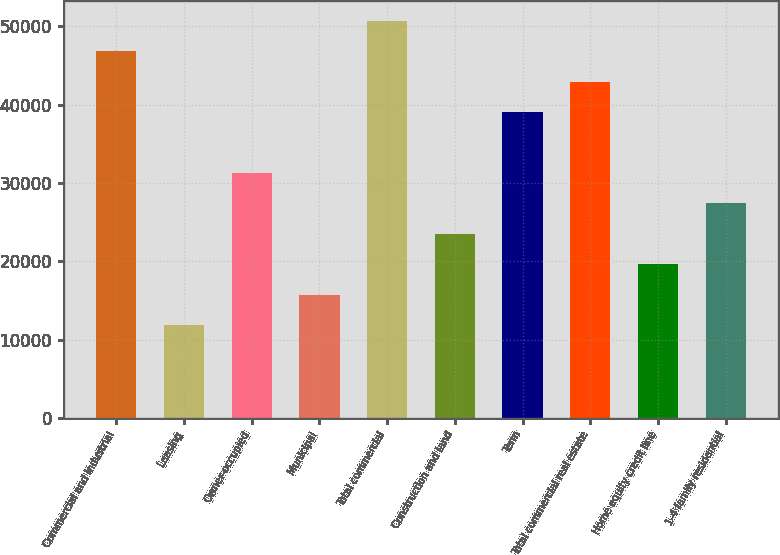Convert chart. <chart><loc_0><loc_0><loc_500><loc_500><bar_chart><fcel>Commercial and industrial<fcel>Leasing<fcel>Owner-occupied<fcel>Municipal<fcel>Total commercial<fcel>Construction and land<fcel>Term<fcel>Total commercial real estate<fcel>Home equity credit line<fcel>1-4 family residential<nl><fcel>46810<fcel>11858.5<fcel>31276<fcel>15742<fcel>50693.5<fcel>23509<fcel>39043<fcel>42926.5<fcel>19625.5<fcel>27392.5<nl></chart> 